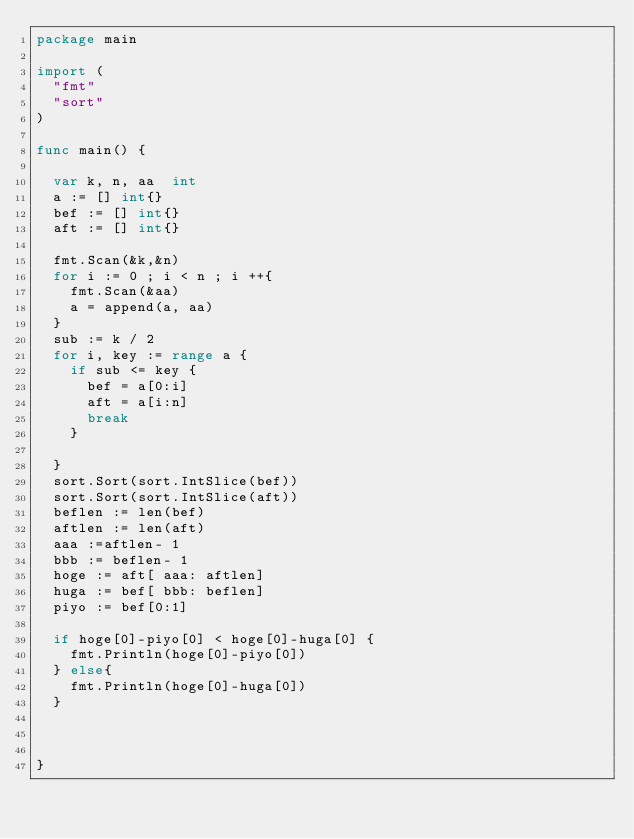<code> <loc_0><loc_0><loc_500><loc_500><_Go_>package main
 
import (
	"fmt"
	"sort" 
)
 
func main() {
 
	var k, n, aa  int 
	a := [] int{}
	bef := [] int{}
	aft := [] int{}  
 
	fmt.Scan(&k,&n)
	for i := 0 ; i < n ; i ++{ 
		fmt.Scan(&aa)
		a = append(a, aa)
	}
	sub := k / 2 
	for i, key := range a {
		if sub <= key {
			bef = a[0:i]
			aft = a[i:n]
			break 
		} 
		
	}
	sort.Sort(sort.IntSlice(bef))
	sort.Sort(sort.IntSlice(aft))	
	beflen := len(bef)
	aftlen := len(aft)
	aaa :=aftlen- 1
	bbb := beflen- 1
	hoge := aft[ aaa: aftlen]
	huga := bef[ bbb: beflen]
	piyo := bef[0:1]

	if hoge[0]-piyo[0] < hoge[0]-huga[0] {
		fmt.Println(hoge[0]-piyo[0])
	} else{
		fmt.Println(hoge[0]-huga[0])
	} 


 
}</code> 